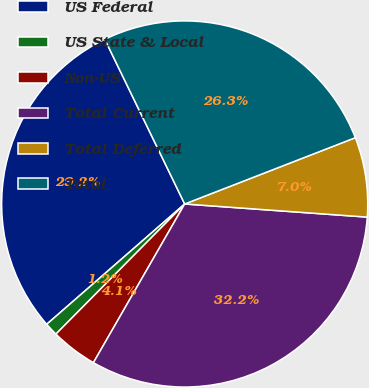Convert chart. <chart><loc_0><loc_0><loc_500><loc_500><pie_chart><fcel>US Federal<fcel>US State & Local<fcel>Non-US<fcel>Total Current<fcel>Total Deferred<fcel>Total<nl><fcel>29.22%<fcel>1.17%<fcel>4.11%<fcel>32.16%<fcel>7.04%<fcel>26.29%<nl></chart> 